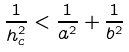<formula> <loc_0><loc_0><loc_500><loc_500>\frac { 1 } { h _ { c } ^ { 2 } } < \frac { 1 } { a ^ { 2 } } + \frac { 1 } { b ^ { 2 } }</formula> 